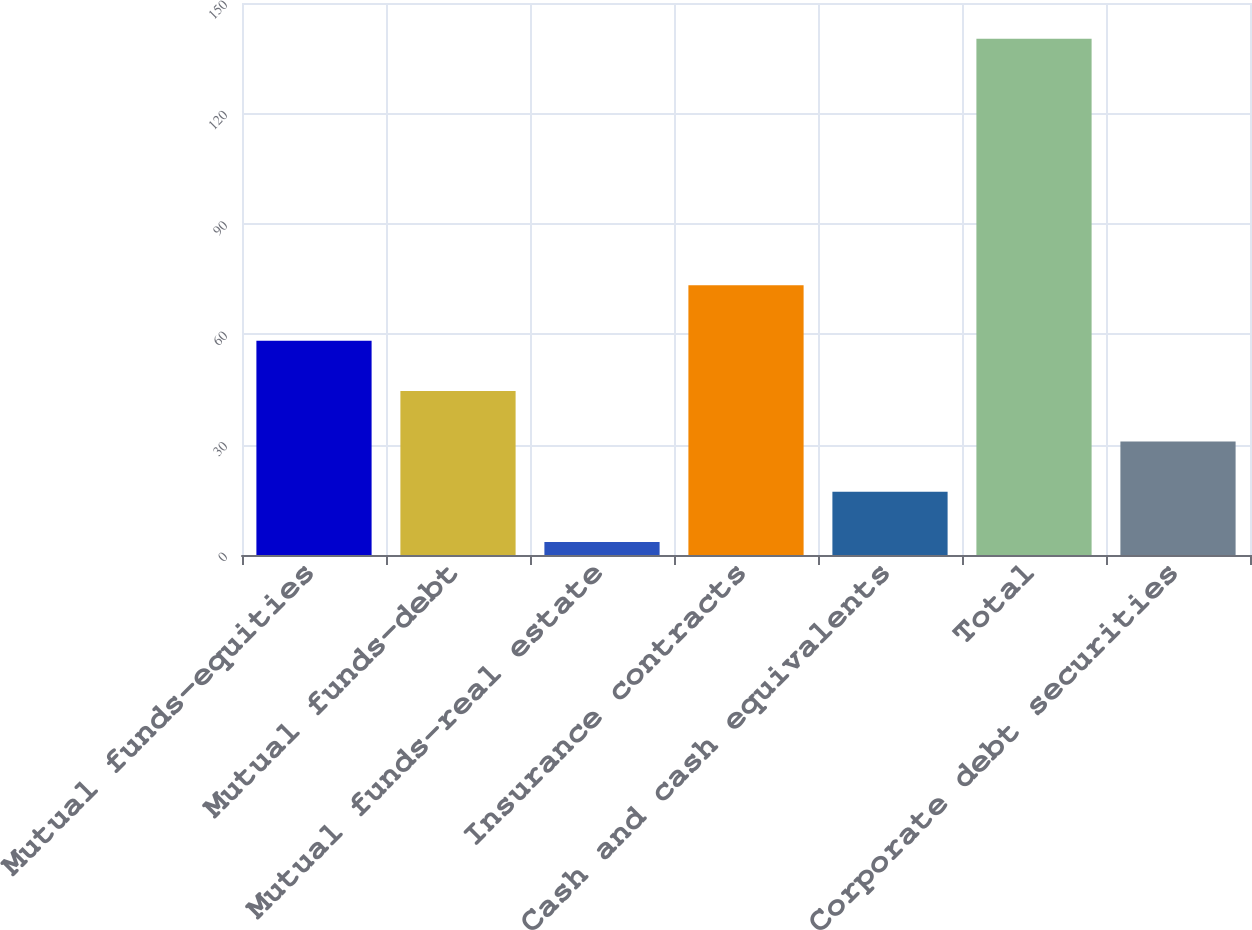<chart> <loc_0><loc_0><loc_500><loc_500><bar_chart><fcel>Mutual funds-equities<fcel>Mutual funds-debt<fcel>Mutual funds-real estate<fcel>Insurance contracts<fcel>Cash and cash equivalents<fcel>Total<fcel>Corporate debt securities<nl><fcel>58.22<fcel>44.54<fcel>3.5<fcel>73.3<fcel>17.18<fcel>140.3<fcel>30.86<nl></chart> 